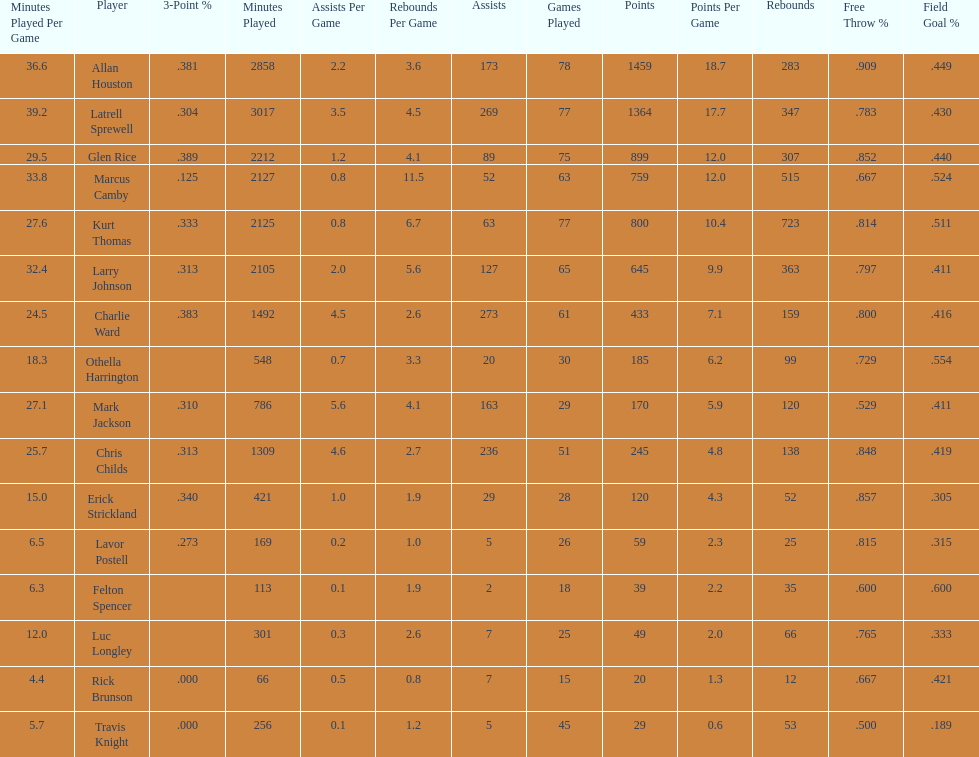How many players had a field goal percentage greater than .500? 4. 